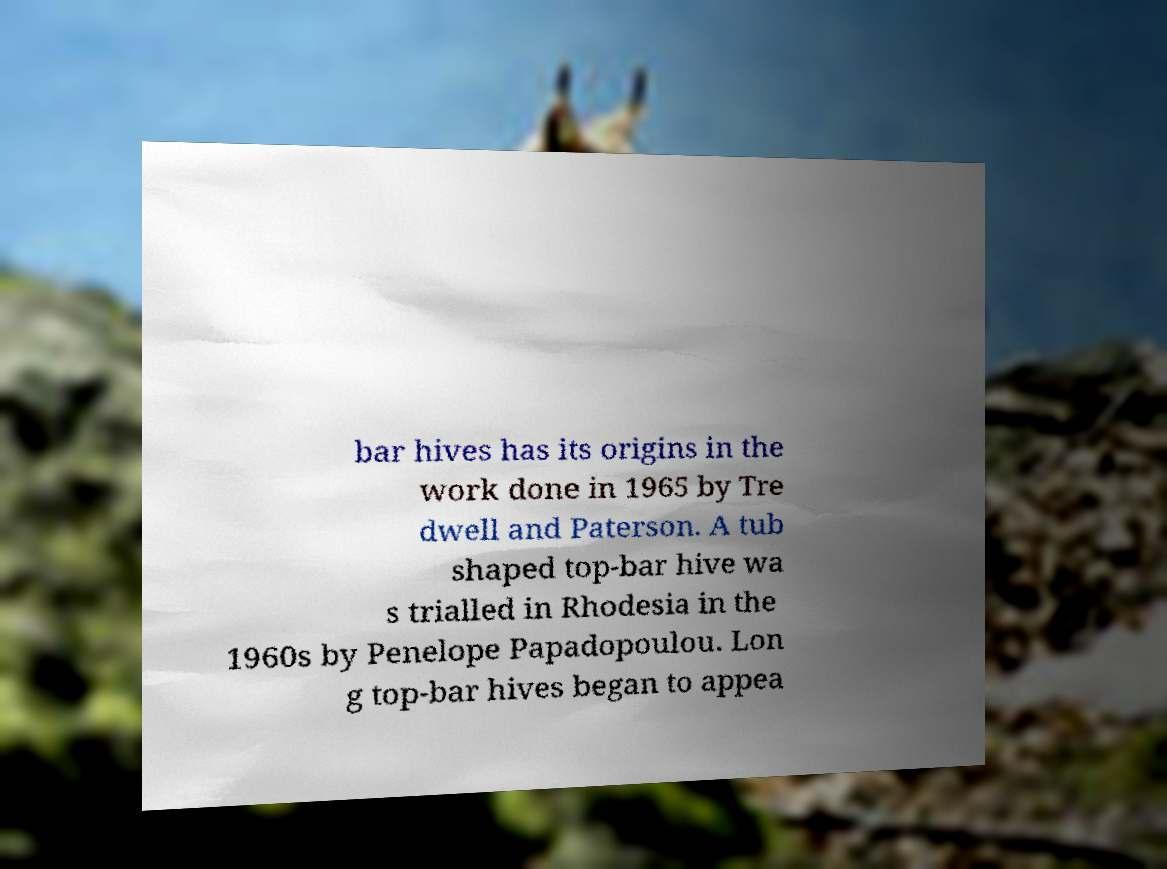There's text embedded in this image that I need extracted. Can you transcribe it verbatim? bar hives has its origins in the work done in 1965 by Tre dwell and Paterson. A tub shaped top-bar hive wa s trialled in Rhodesia in the 1960s by Penelope Papadopoulou. Lon g top-bar hives began to appea 